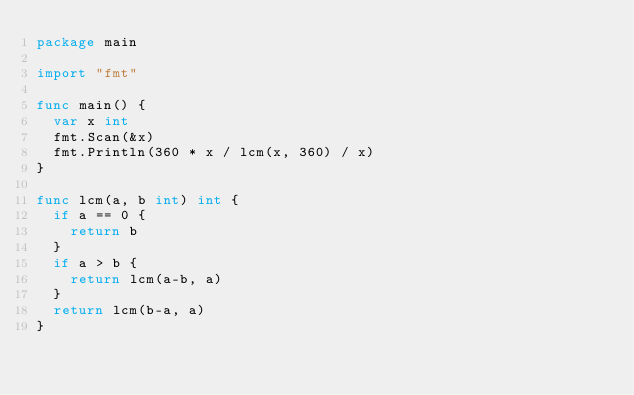Convert code to text. <code><loc_0><loc_0><loc_500><loc_500><_Go_>package main

import "fmt"

func main() {
	var x int
	fmt.Scan(&x)
	fmt.Println(360 * x / lcm(x, 360) / x)
}

func lcm(a, b int) int {
	if a == 0 {
		return b
	}
	if a > b {
		return lcm(a-b, a)
	}
	return lcm(b-a, a)
}
</code> 